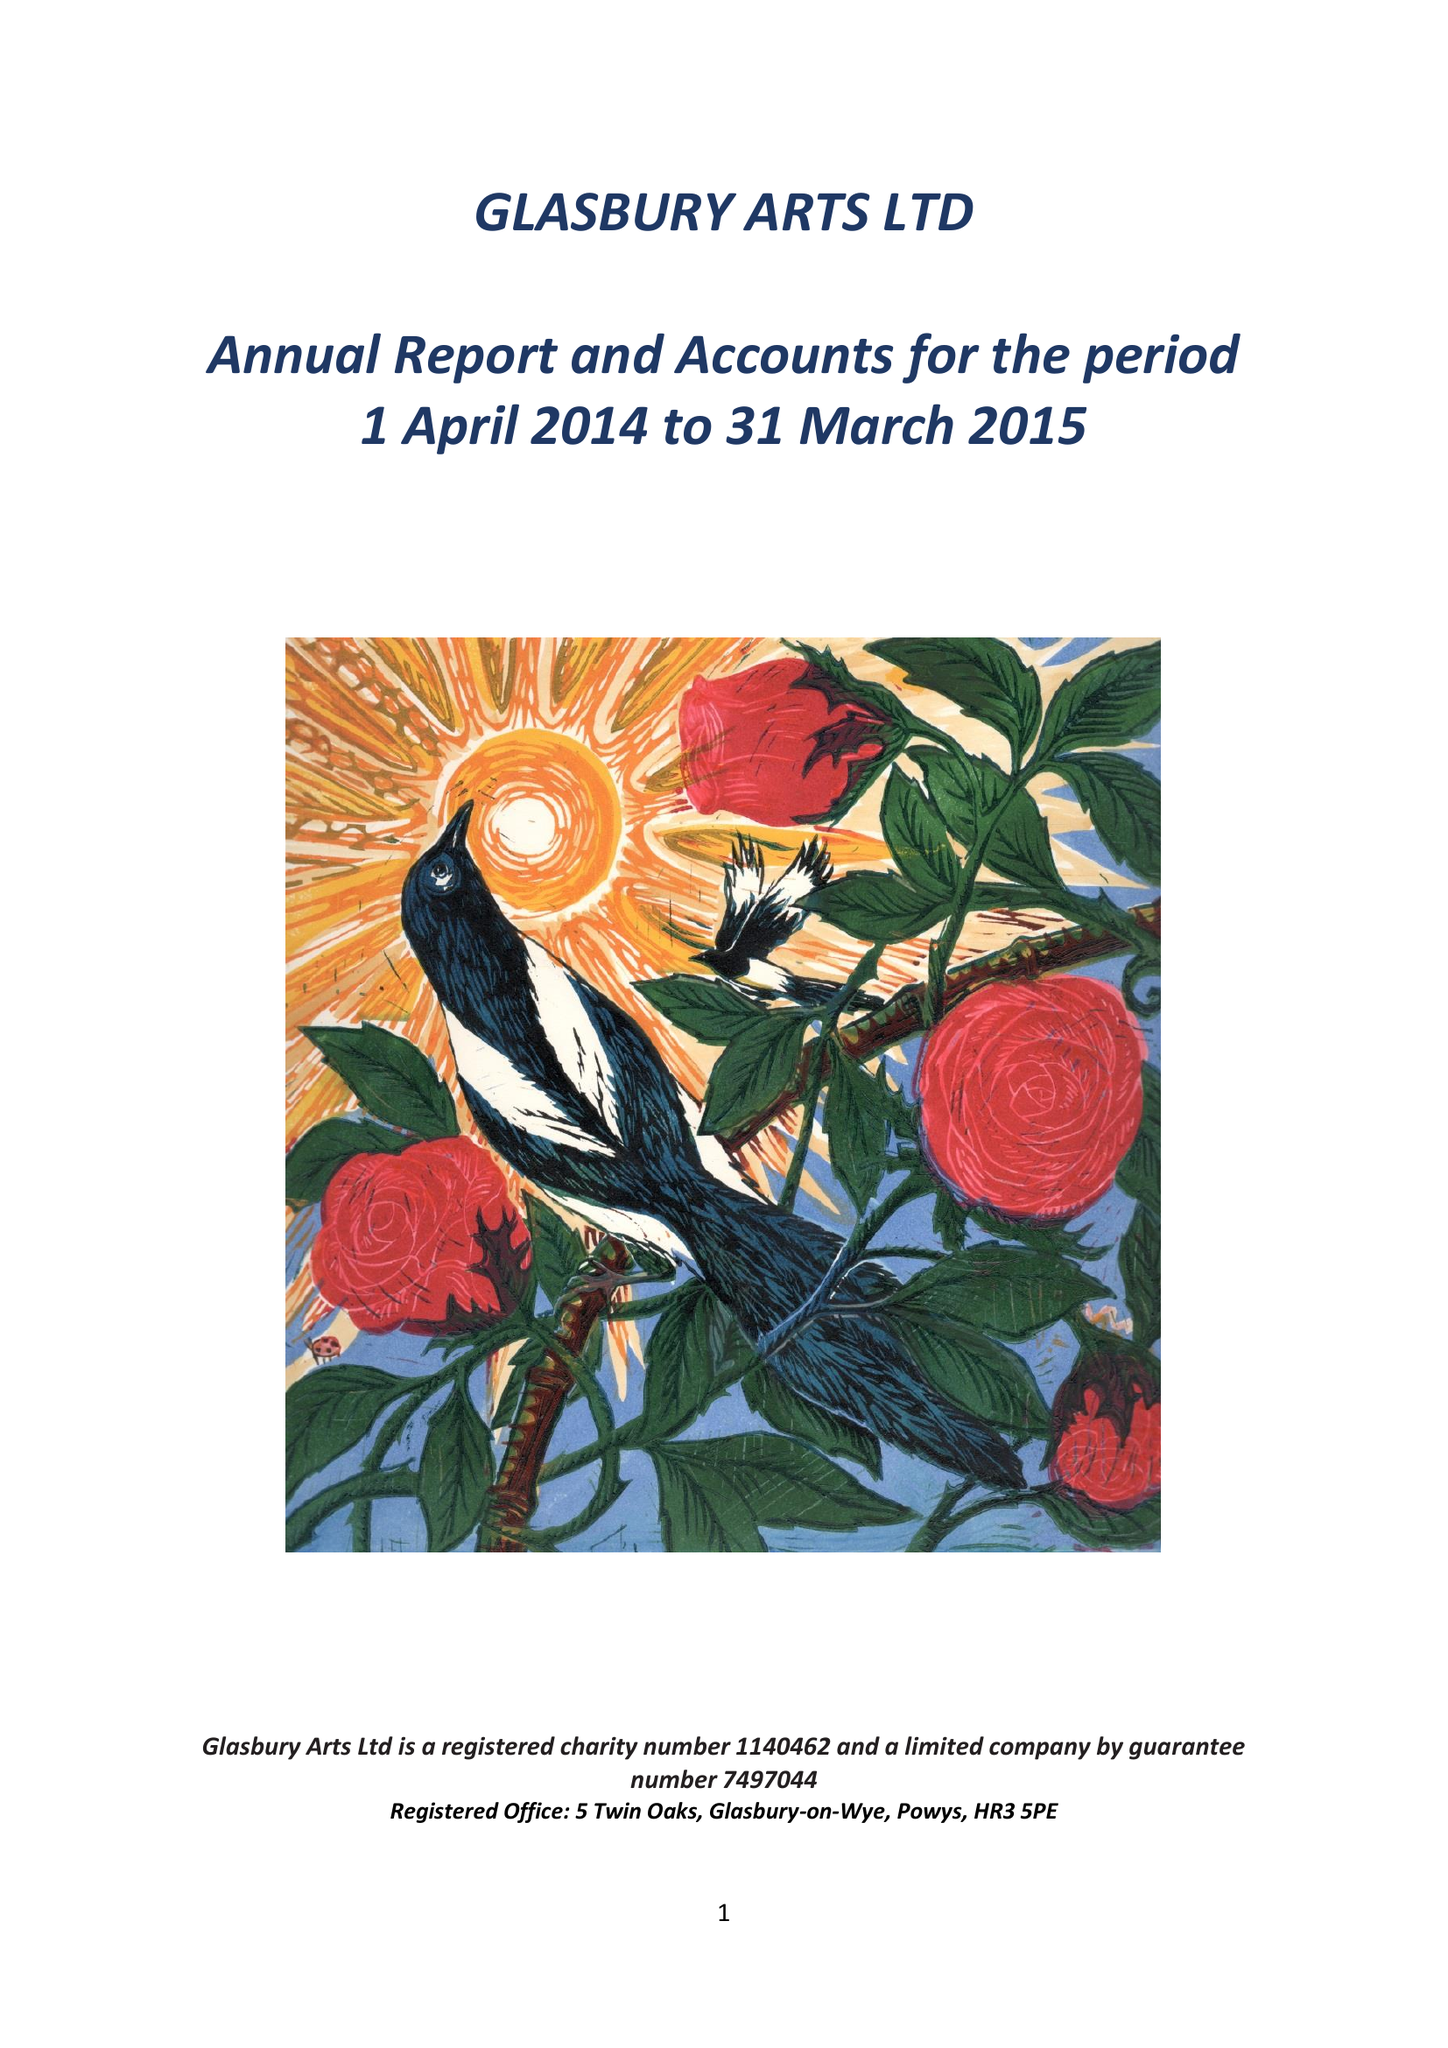What is the value for the address__street_line?
Answer the question using a single word or phrase. None 